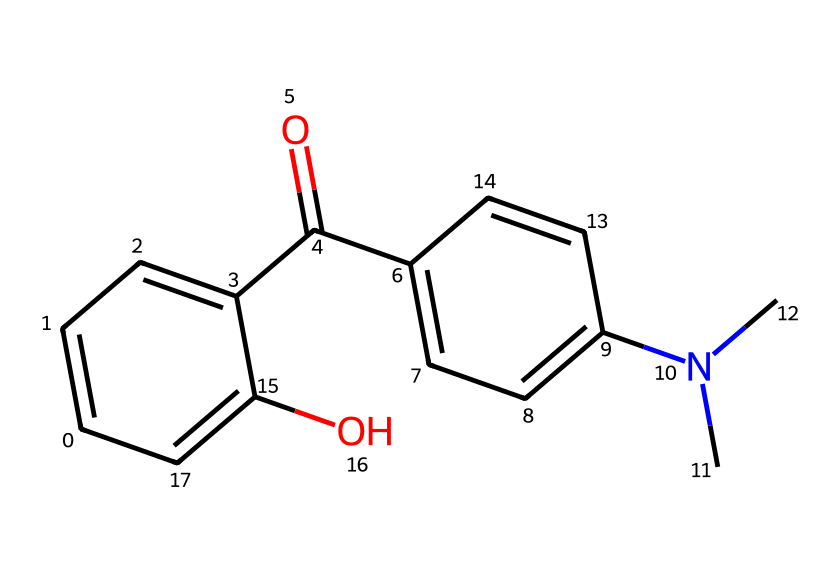What is the total number of carbon atoms in this structure? To find the total number of carbon atoms, count the carbon atoms represented in the SMILES notation. The structure has a total of fifteen carbon atoms.
Answer: fifteen How many nitrogen atoms are present in this compound? By examining the SMILES representation, we find one nitrogen atom is indicated by the "N" in the side chain.
Answer: one What functional group is represented by "C(=O)"? The "C(=O)" notation indicates the presence of a carbonyl functional group, specifically a ketone or aldehyde. In this chemical, it is part of a ketone functional group.
Answer: carbonyl Which part of the molecule suggests it has amine characteristics? The presence of "N(C)C" indicates that the molecule contains a nitrogen atom bonded to two carbon atoms, characteristic of a tertiary amine.
Answer: tertiary amine What is the type of aromatic compound represented in the structure? The multiple connected carbon rings illustrate that it is a polycyclic aromatic compound due to its fused aromatic rings.
Answer: polycyclic aromatic Are there any hydroxyl groups in this chemical? Yes, the "c(O)" notation indicates the presence of a hydroxyl group (–OH) attached to one of the aromatic rings.
Answer: yes 